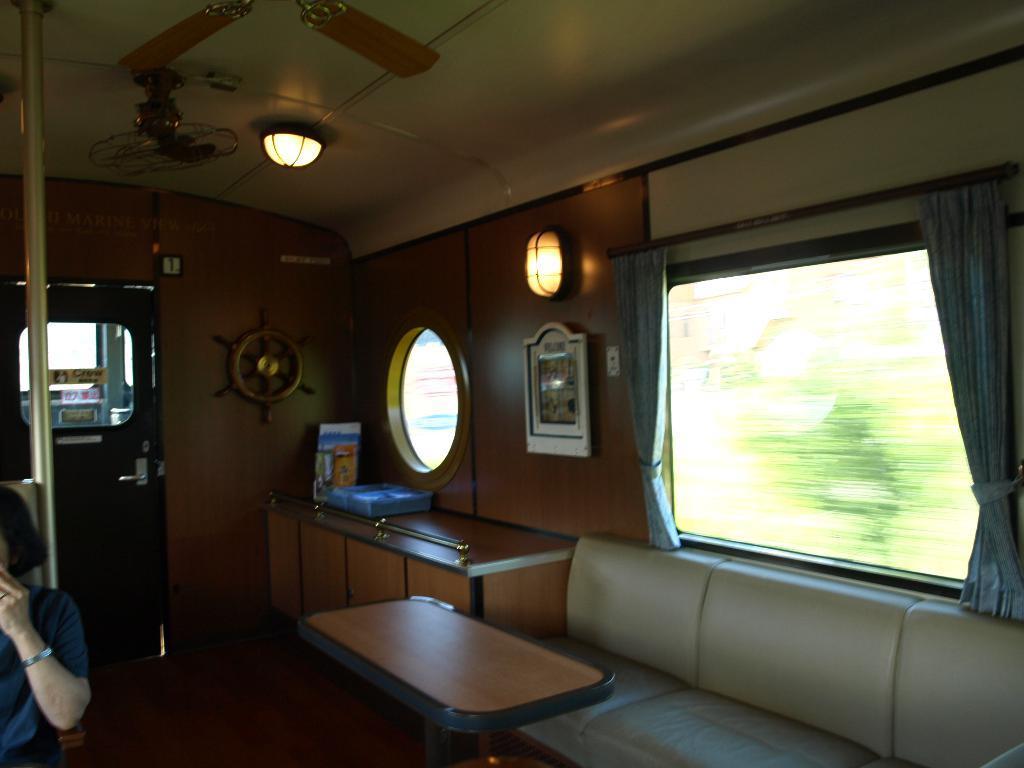Please provide a concise description of this image. This is the inside picture of the vehicle. In this image there is a sofa. There is a table. There is a wooden platform. On top of it there are a few objects. There is a glass window. There are curtains. There are lights. On top of the image there is a fan. There is a door. On the left side of the image there is a person sitting on the chair. At the bottom of the image there is a floor. There are some objects attached to the wall. 